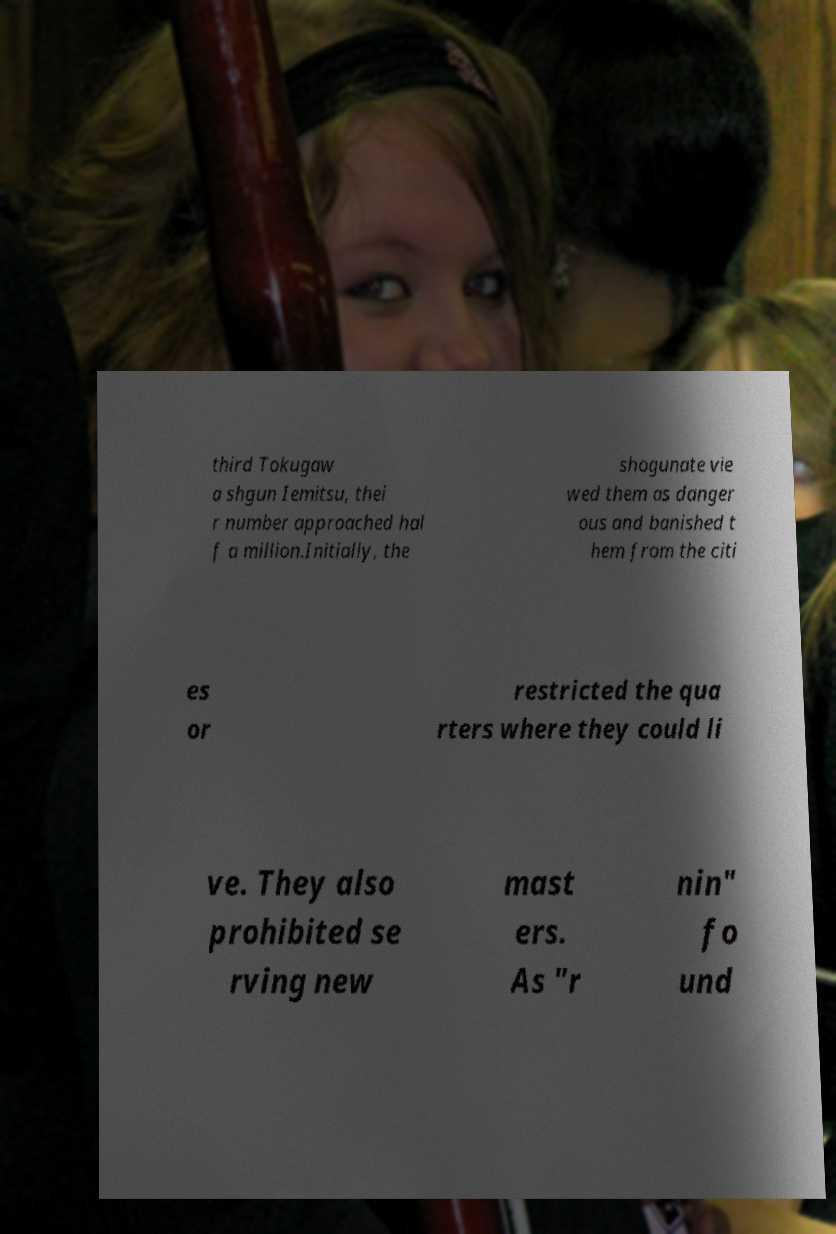Can you accurately transcribe the text from the provided image for me? third Tokugaw a shgun Iemitsu, thei r number approached hal f a million.Initially, the shogunate vie wed them as danger ous and banished t hem from the citi es or restricted the qua rters where they could li ve. They also prohibited se rving new mast ers. As "r nin" fo und 